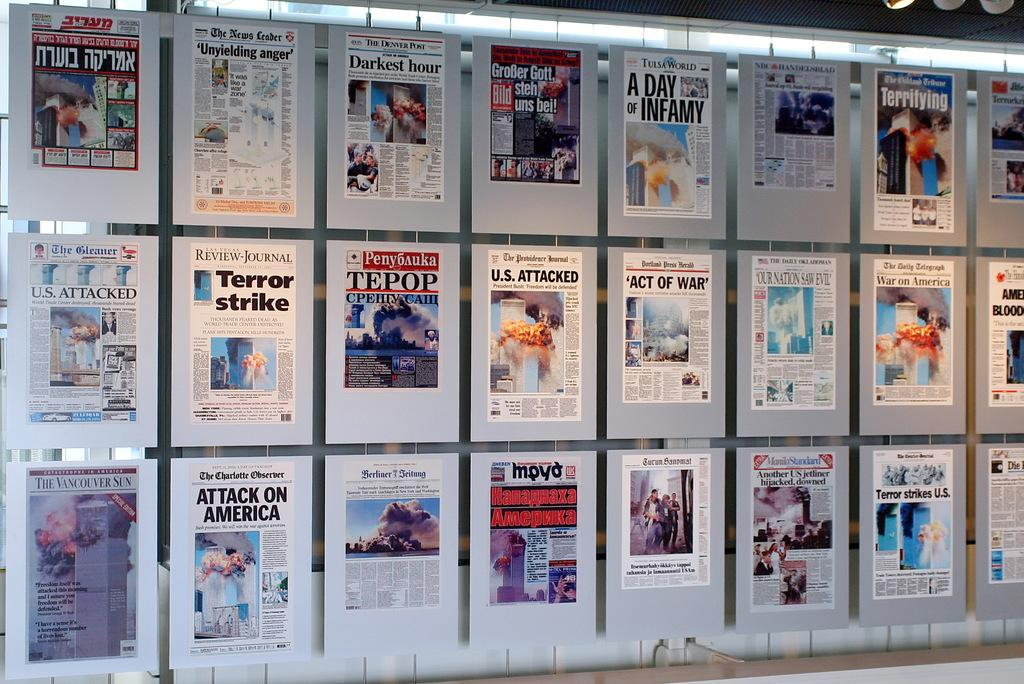Provide a one-sentence caption for the provided image. Billboard showing different news on america and the U.S being attacked. 